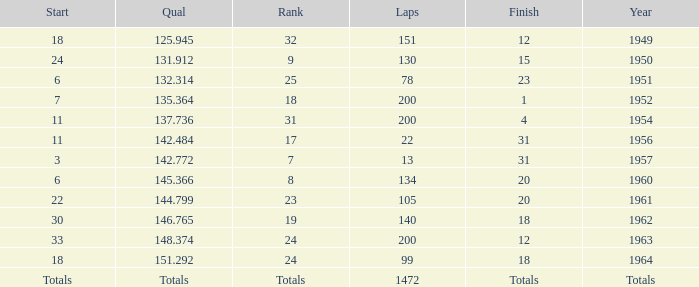Name the year for laps of 200 and rank of 24 1963.0. 